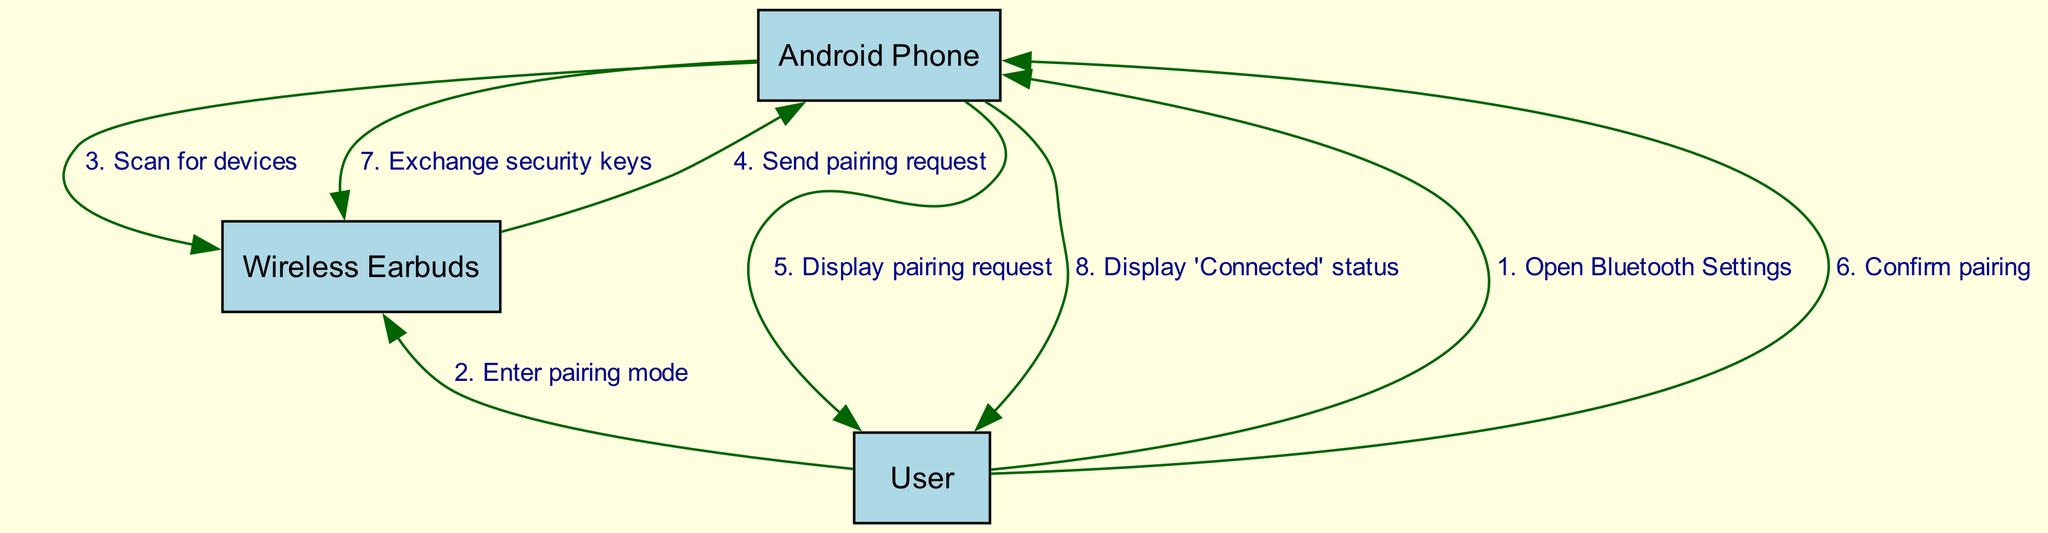What action does the user take first? The user opens the Bluetooth settings, which is the first message in the sequence diagram. This is indicated by the first interaction labeled "Open Bluetooth Settings."
Answer: Open Bluetooth Settings How many participants are involved in the Bluetooth pairing process? Three participants are shown in the diagram: the Android Phone, Wireless Earbuds, and User. The count of nodes representing participants confirms this.
Answer: Three What message is sent from the Wireless Earbuds to the Android Phone? The Wireless Earbuds send a "Send pairing request" message to the Android Phone. This is clearly labeled as the fourth message in the sequence.
Answer: Send pairing request Which participant displays the 'Connected' status? The Android Phone displays the 'Connected' status, as indicated by the last message directed to the User in the diagram.
Answer: Android Phone What occurs right after the user confirms pairing? After the user confirms pairing, the next action is the Android Phone exchanging security keys with the Wireless Earbuds. This link is shown as the sixth message followed by the seventh.
Answer: Exchange security keys How many messages are exchanged between the User and the Android Phone? There are a total of three messages exchanged between the User and the Android Phone: opening Bluetooth settings, confirming pairing, and displaying the 'Connected' status. This can be traced throughout the diagram.
Answer: Three What is the sequence of the first three actions? The first three actions in the sequence are: "Open Bluetooth Settings" by the User, "Enter pairing mode" by the User, and "Scan for devices" by the Android Phone. These messages indicate the initial steps of the pairing process.
Answer: Open Bluetooth Settings, Enter pairing mode, Scan for devices Which participant initiates the scanning for devices? The Android Phone initiates the scanning for devices, as shown by the third message directed to the Wireless Earbuds.
Answer: Android Phone 